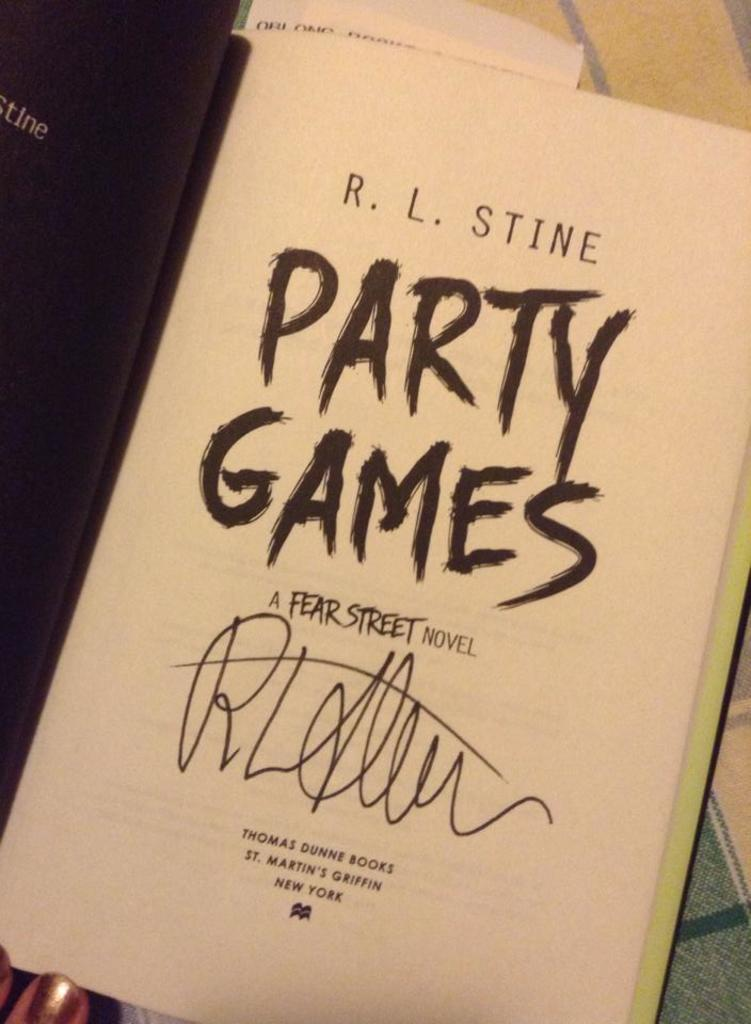Provide a one-sentence caption for the provided image. A page in the book Party Games by R.L. Stine. 